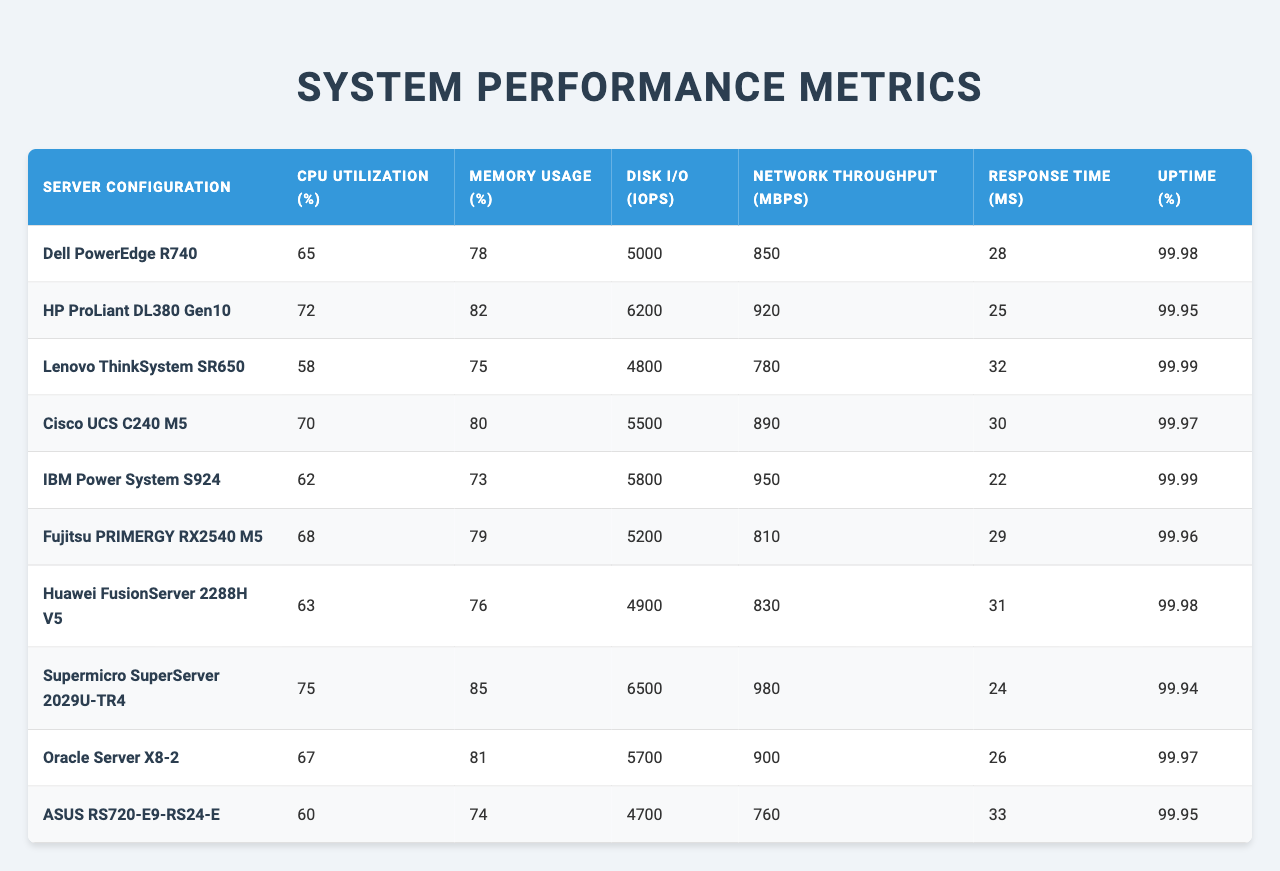What is the CPU Utilization percentage for the Dell PowerEdge R740? The table shows the CPU Utilization percentage for the Dell PowerEdge R740, which is listed as 65%.
Answer: 65% Which server has the highest Memory Usage percentage? By comparing the Memory Usage percentages in the table, the server with the highest Memory Usage is the Supermicro SuperServer 2029U-TR4 at 85%.
Answer: Supermicro SuperServer 2029U-TR4 What is the Disk I/O (IOPS) for the Lenovo ThinkSystem SR650? The Lenovo ThinkSystem SR650 has a Disk I/O (IOPS) value of 4800, as indicated in the table.
Answer: 4800 Is the Uptime percentage for the HP ProLiant DL380 Gen10 greater than 99.95%? The Uptime percentage for the HP ProLiant DL380 Gen10 is 99.95%, which means it is not greater than 99.95%.
Answer: No What is the average Network Throughput for all the servers? The total Network Throughput is 850 + 920 + 780 + 890 + 950 + 810 + 830 + 980 + 900 + 760 = 9,410 Mbps. Dividing by the number of servers (10) gives an average of 941 Mbps.
Answer: 941 Mbps Which server has the best Response Time and what is that time? The Response Time for all servers needs to be compared; the lowest is 22 ms for the IBM Power System S924.
Answer: IBM Power System S924, 22 ms What is the difference in CPU Utilization between the highest and lowest values? The highest CPU Utilization is 75% (Supermicro SuperServer 2029U-TR4) and the lowest is 58% (Lenovo ThinkSystem SR650). The difference is 75% - 58% = 17%.
Answer: 17% Are the Memory Usage percentages for the Dell PowerEdge R740 and Huawei FusionServer 2288H V5 equal? The Memory Usage for the Dell PowerEdge R740 is 78% and for Huawei FusionServer 2288H V5, it is 76%, which confirms they are not equal.
Answer: No Which server configuration has both the highest Uptime and Disk I/O? The server with the highest Uptime is Lenovo ThinkSystem SR650 at 99.99% with a Disk I/O of 4800. The server with the highest Disk I/O is Supermicro SuperServer 2029U-TR4 at 6500 but has a slightly lower Uptime of 99.94%. Thus, no single server has both max values.
Answer: None What is the total Response Time for all servers? The sum of Response Times is 28 + 25 + 32 + 30 + 22 + 29 + 31 + 24 + 26 + 33 =  8,70 ms.
Answer: 8,70 ms 